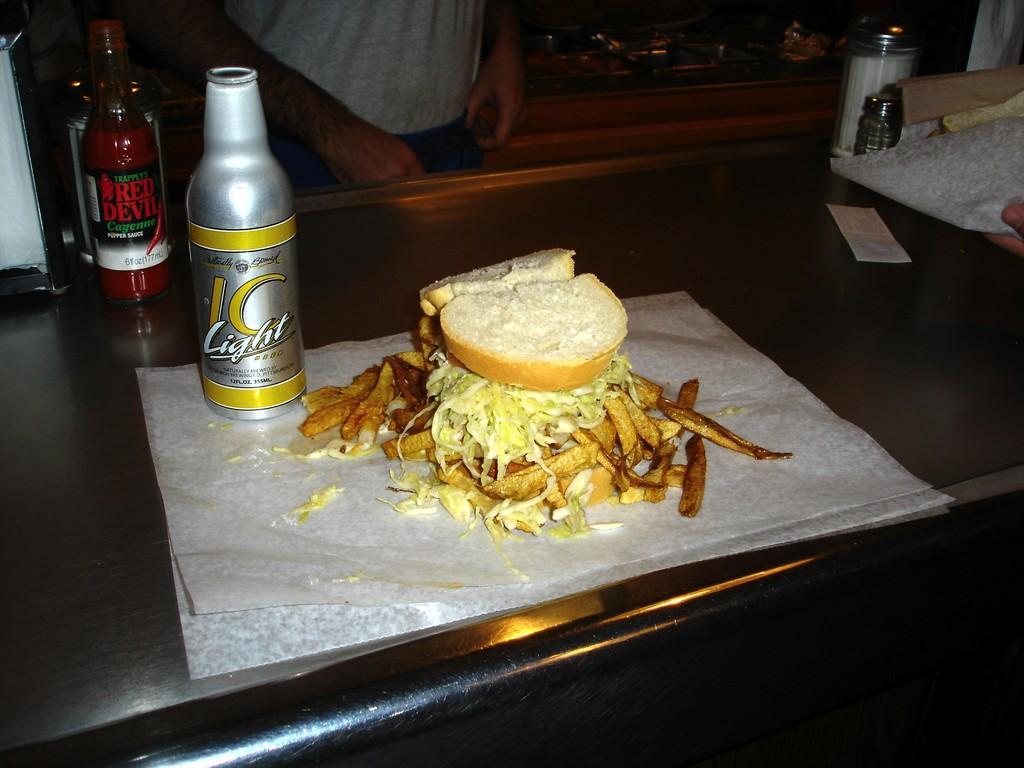How would you summarize this image in a sentence or two? In a picture a table is there and two bottles are on it and one burger with some fries along with tissue paper is present on it, in front of the table there is one person standing and there are two jars present in the picture. 